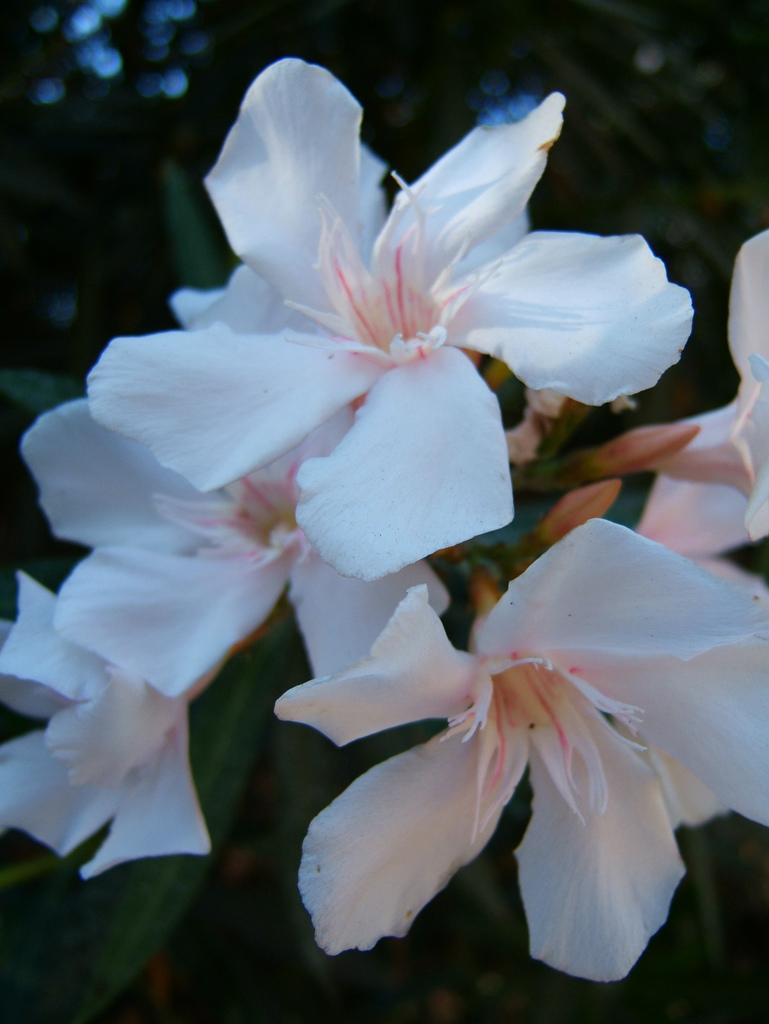What type of flowers can be seen in the image? There are white color flowers in the image. Can you describe the background of the image? The background of the image is black and green. What hobbies does the secretary have, as seen in the image? There is no secretary present in the image, so it is not possible to determine their hobbies. 